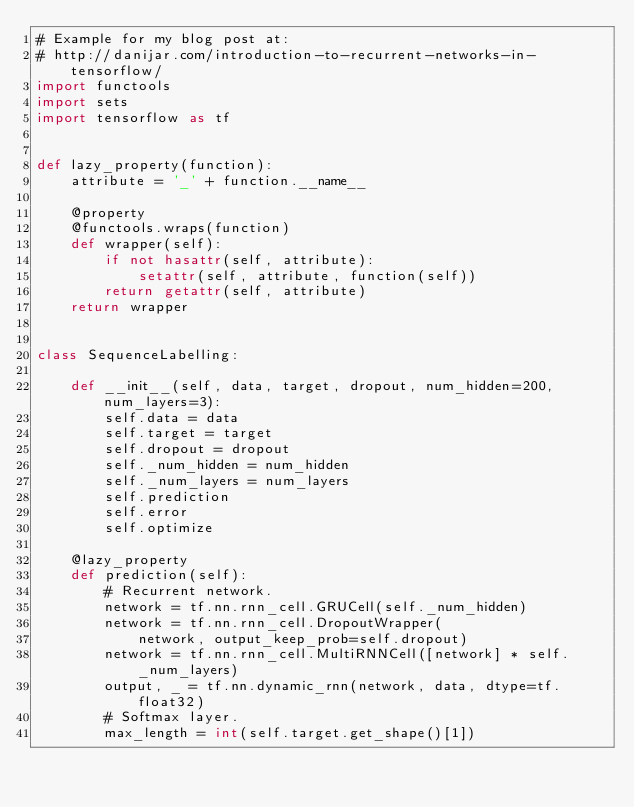Convert code to text. <code><loc_0><loc_0><loc_500><loc_500><_Python_># Example for my blog post at:
# http://danijar.com/introduction-to-recurrent-networks-in-tensorflow/
import functools
import sets
import tensorflow as tf


def lazy_property(function):
    attribute = '_' + function.__name__

    @property
    @functools.wraps(function)
    def wrapper(self):
        if not hasattr(self, attribute):
            setattr(self, attribute, function(self))
        return getattr(self, attribute)
    return wrapper


class SequenceLabelling:

    def __init__(self, data, target, dropout, num_hidden=200, num_layers=3):
        self.data = data
        self.target = target
        self.dropout = dropout
        self._num_hidden = num_hidden
        self._num_layers = num_layers
        self.prediction
        self.error
        self.optimize

    @lazy_property
    def prediction(self):
        # Recurrent network.
        network = tf.nn.rnn_cell.GRUCell(self._num_hidden)
        network = tf.nn.rnn_cell.DropoutWrapper(
            network, output_keep_prob=self.dropout)
        network = tf.nn.rnn_cell.MultiRNNCell([network] * self._num_layers)
        output, _ = tf.nn.dynamic_rnn(network, data, dtype=tf.float32)
        # Softmax layer.
        max_length = int(self.target.get_shape()[1])</code> 